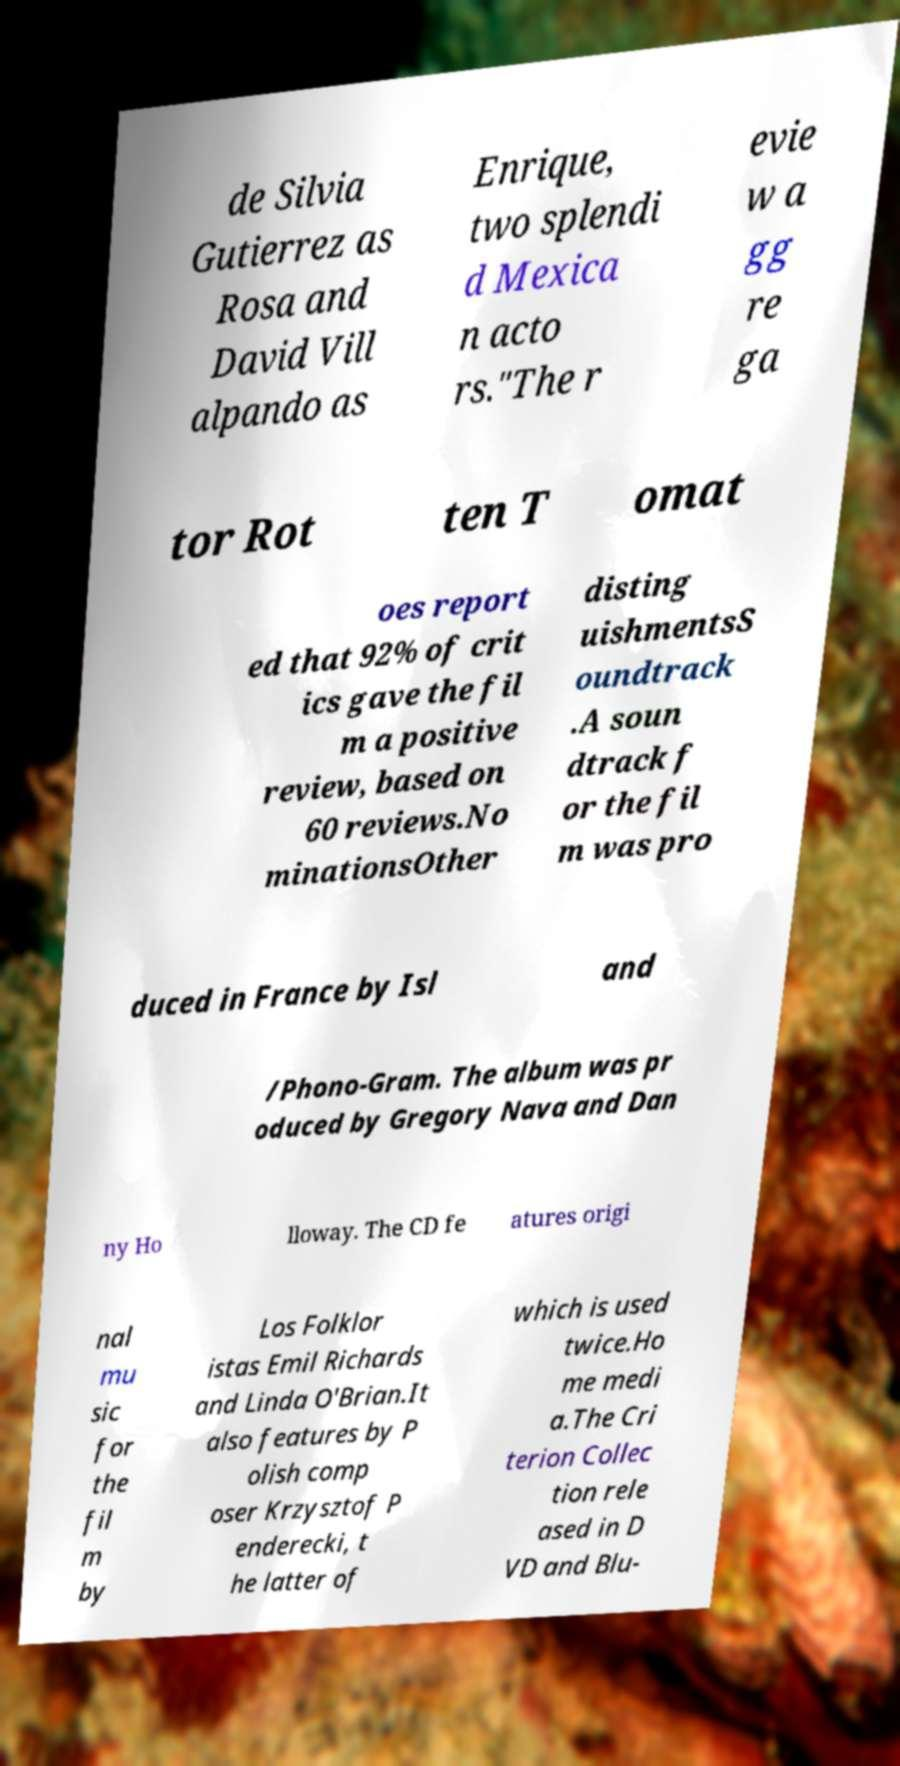Could you extract and type out the text from this image? de Silvia Gutierrez as Rosa and David Vill alpando as Enrique, two splendi d Mexica n acto rs."The r evie w a gg re ga tor Rot ten T omat oes report ed that 92% of crit ics gave the fil m a positive review, based on 60 reviews.No minationsOther disting uishmentsS oundtrack .A soun dtrack f or the fil m was pro duced in France by Isl and /Phono-Gram. The album was pr oduced by Gregory Nava and Dan ny Ho lloway. The CD fe atures origi nal mu sic for the fil m by Los Folklor istas Emil Richards and Linda O'Brian.It also features by P olish comp oser Krzysztof P enderecki, t he latter of which is used twice.Ho me medi a.The Cri terion Collec tion rele ased in D VD and Blu- 